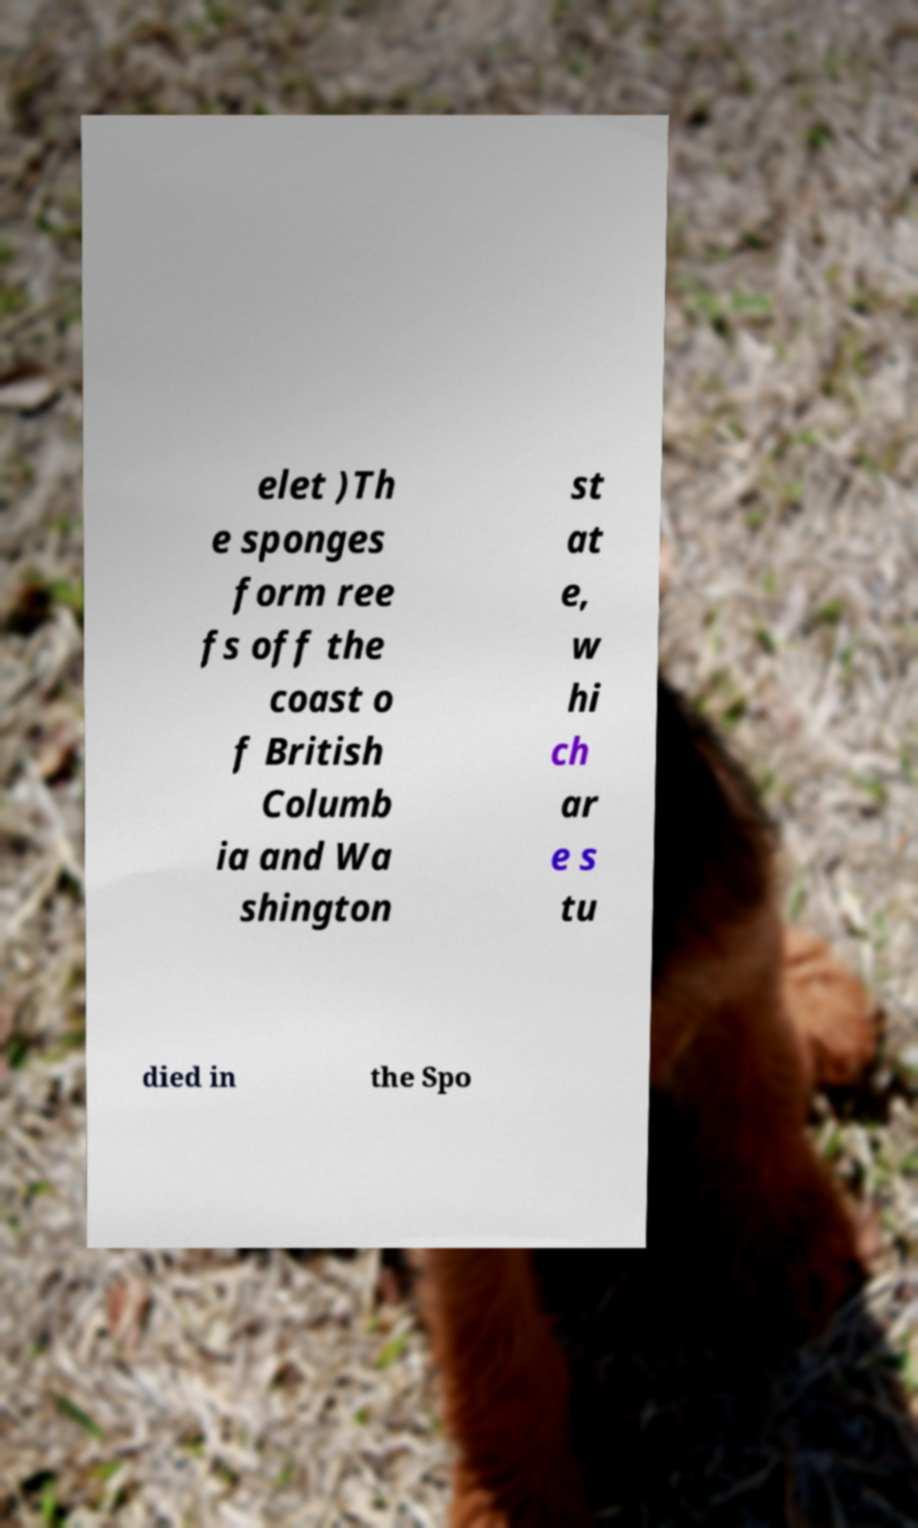Can you read and provide the text displayed in the image?This photo seems to have some interesting text. Can you extract and type it out for me? elet )Th e sponges form ree fs off the coast o f British Columb ia and Wa shington st at e, w hi ch ar e s tu died in the Spo 